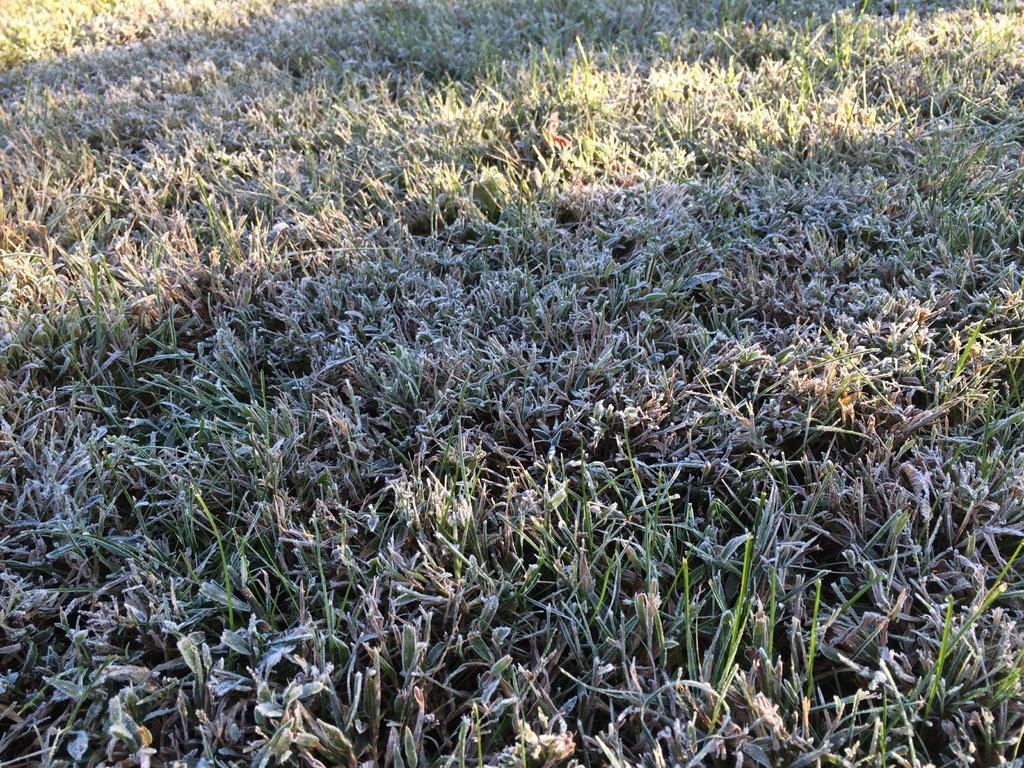What type of vegetation can be seen in the image? There are plants and grass in the image. Can you describe the natural setting in the image? The natural setting in the image includes plants and grass. How many sheep are grazing in the grass in the image? There are no sheep present in the image; it only features plants and grass. What type of bird can be seen flying over the plants in the image? There are no birds visible in the image; it only features plants and grass. 